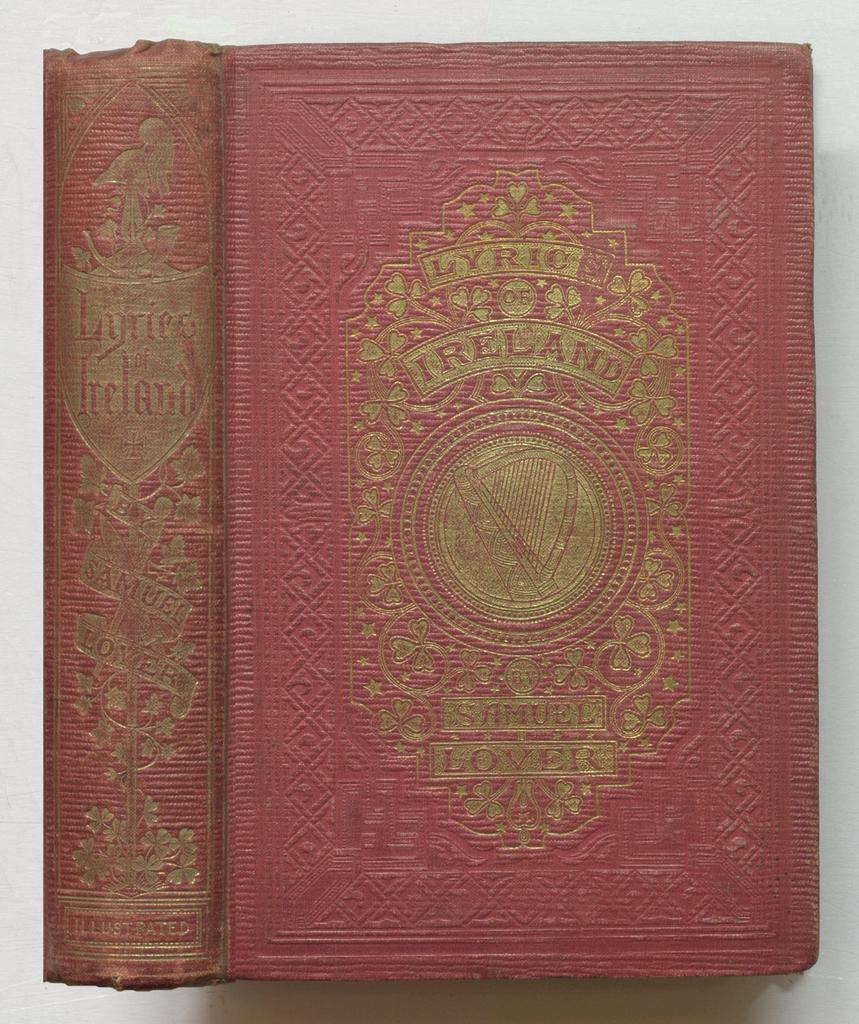<image>
Relay a brief, clear account of the picture shown. The front cover and spine of the book Lyric Of Ireland. 